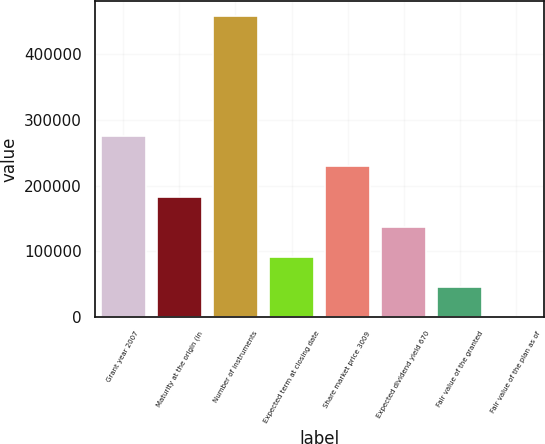Convert chart. <chart><loc_0><loc_0><loc_500><loc_500><bar_chart><fcel>Grant year 2007<fcel>Maturity at the origin (in<fcel>Number of instruments<fcel>Expected term at closing date<fcel>Share market price 3009<fcel>Expected dividend yield 670<fcel>Fair value of the granted<fcel>Fair value of the plan as of<nl><fcel>275244<fcel>183496<fcel>458740<fcel>91748.6<fcel>229370<fcel>137622<fcel>45874.6<fcel>0.7<nl></chart> 